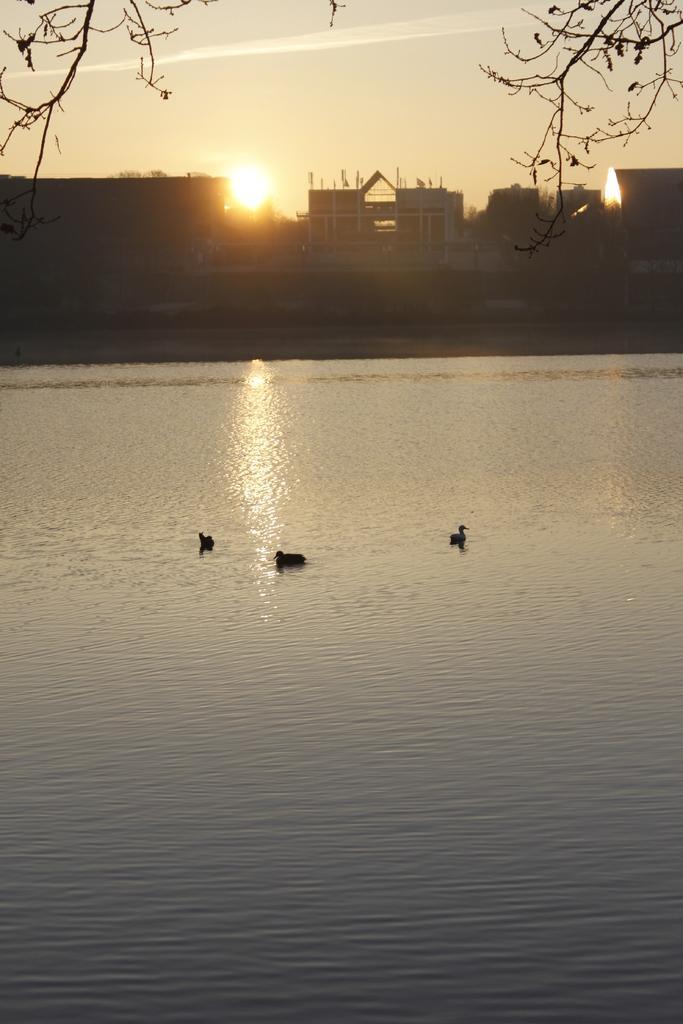Can you describe this image briefly? In this image I can see water in the front and in it I can see few birds. In the background I can see few buildings, the sky, the sun and on the top of this image I can see stems of a tree. 